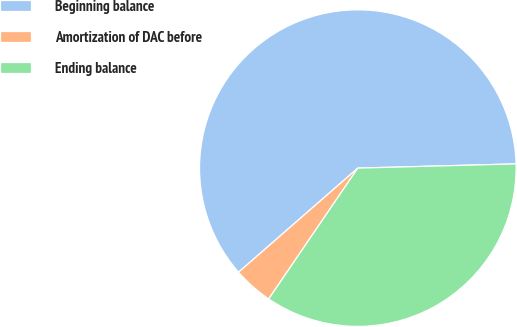<chart> <loc_0><loc_0><loc_500><loc_500><pie_chart><fcel>Beginning balance<fcel>Amortization of DAC before<fcel>Ending balance<nl><fcel>61.0%<fcel>4.06%<fcel>34.94%<nl></chart> 